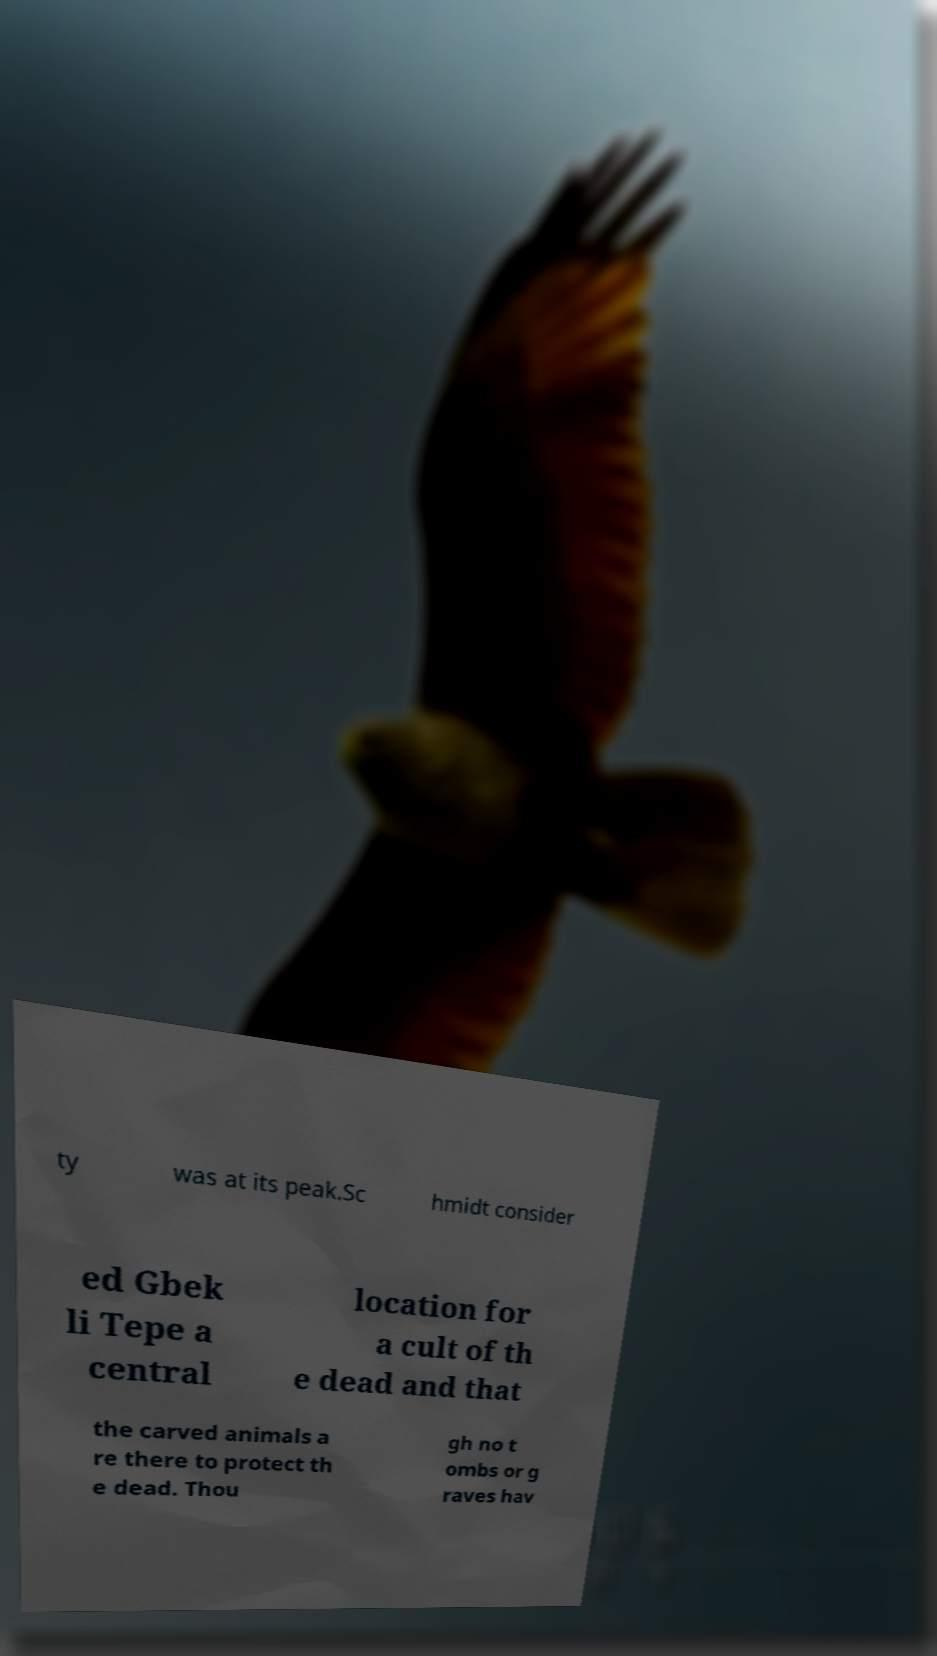Could you assist in decoding the text presented in this image and type it out clearly? ty was at its peak.Sc hmidt consider ed Gbek li Tepe a central location for a cult of th e dead and that the carved animals a re there to protect th e dead. Thou gh no t ombs or g raves hav 